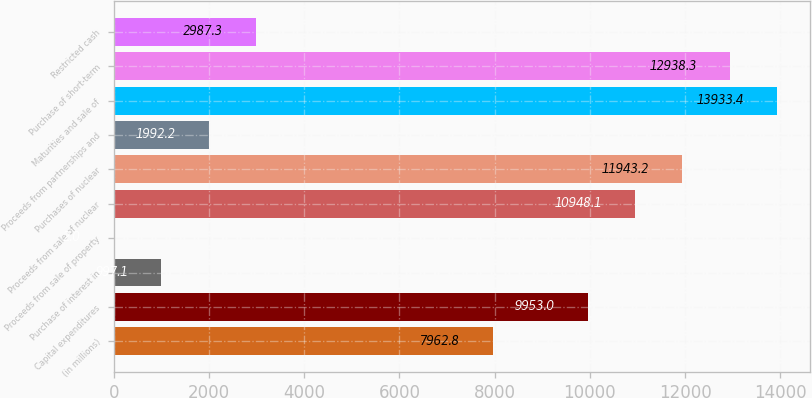Convert chart to OTSL. <chart><loc_0><loc_0><loc_500><loc_500><bar_chart><fcel>(in millions)<fcel>Capital expenditures<fcel>Purchase of interest in<fcel>Proceeds from sale of property<fcel>Proceeds from sale of nuclear<fcel>Purchases of nuclear<fcel>Proceeds from partnerships and<fcel>Maturities and sale of<fcel>Purchase of short-term<fcel>Restricted cash<nl><fcel>7962.8<fcel>9953<fcel>997.1<fcel>2<fcel>10948.1<fcel>11943.2<fcel>1992.2<fcel>13933.4<fcel>12938.3<fcel>2987.3<nl></chart> 